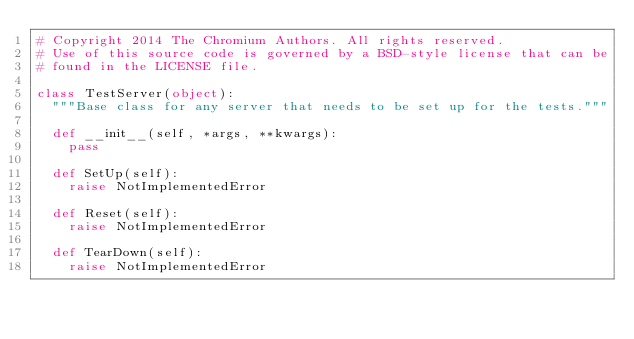<code> <loc_0><loc_0><loc_500><loc_500><_Python_># Copyright 2014 The Chromium Authors. All rights reserved.
# Use of this source code is governed by a BSD-style license that can be
# found in the LICENSE file.

class TestServer(object):
  """Base class for any server that needs to be set up for the tests."""

  def __init__(self, *args, **kwargs):
    pass

  def SetUp(self):
    raise NotImplementedError

  def Reset(self):
    raise NotImplementedError

  def TearDown(self):
    raise NotImplementedError

</code> 